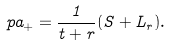<formula> <loc_0><loc_0><loc_500><loc_500>\ p a _ { + } = \frac { 1 } { t + r } ( S + L _ { r } ) .</formula> 